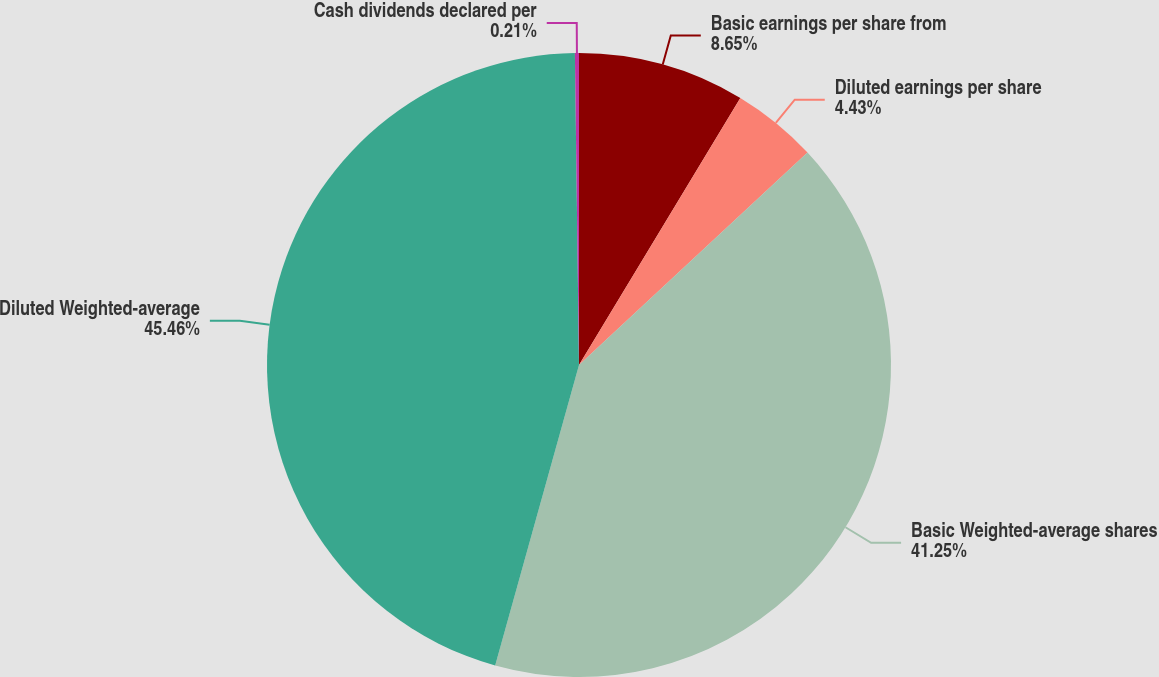Convert chart. <chart><loc_0><loc_0><loc_500><loc_500><pie_chart><fcel>Basic earnings per share from<fcel>Diluted earnings per share<fcel>Basic Weighted-average shares<fcel>Diluted Weighted-average<fcel>Cash dividends declared per<nl><fcel>8.65%<fcel>4.43%<fcel>41.25%<fcel>45.46%<fcel>0.21%<nl></chart> 